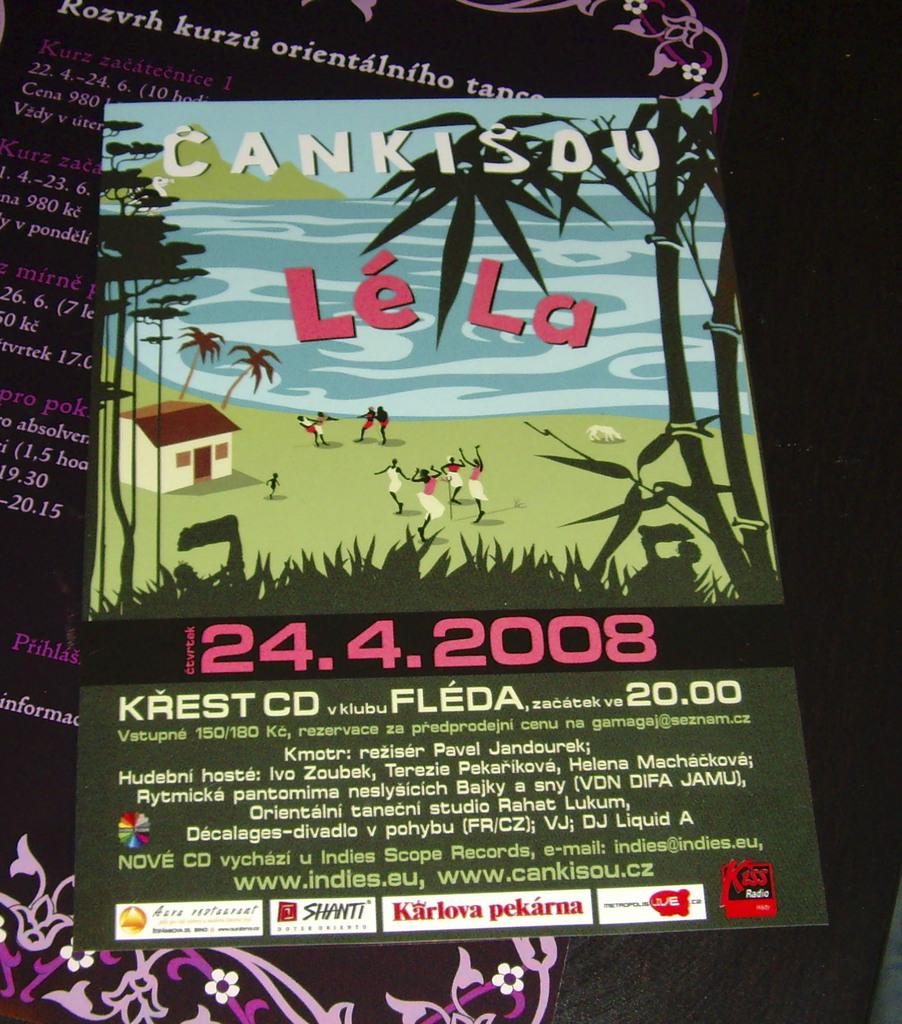What is this a flyer of?
Offer a terse response. Cankisou le la. What date is on the flyer?
Your answer should be very brief. 24.4.2008. 